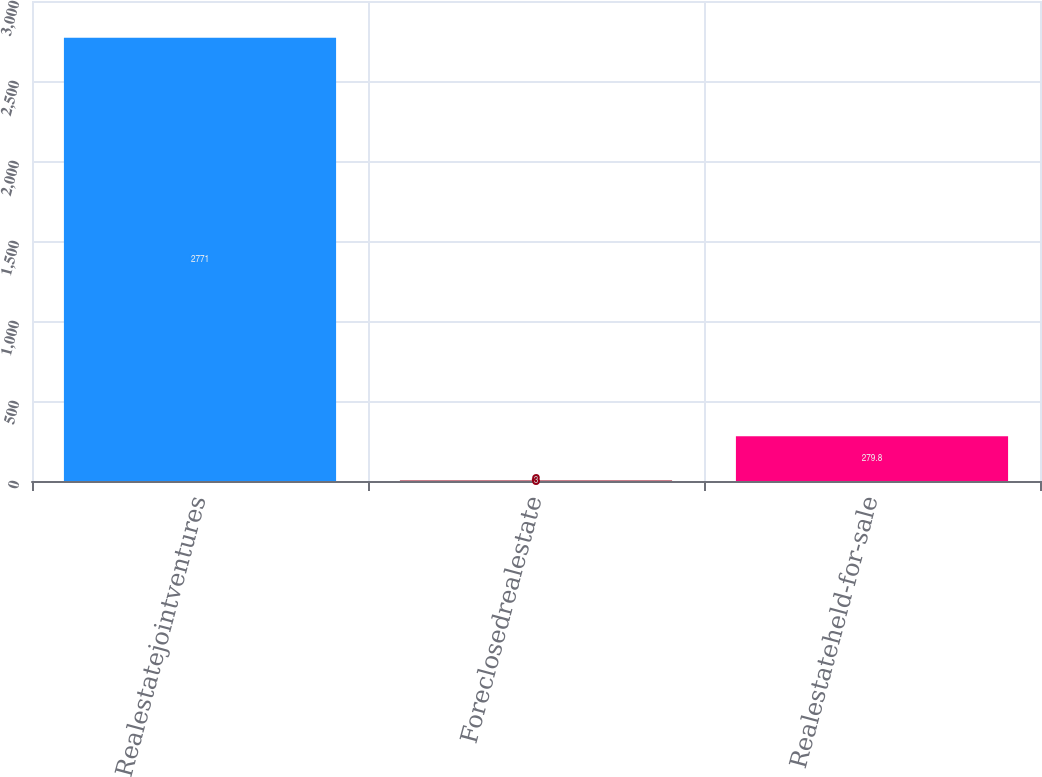Convert chart. <chart><loc_0><loc_0><loc_500><loc_500><bar_chart><fcel>Realestatejointventures<fcel>Foreclosedrealestate<fcel>Realestateheld-for-sale<nl><fcel>2771<fcel>3<fcel>279.8<nl></chart> 